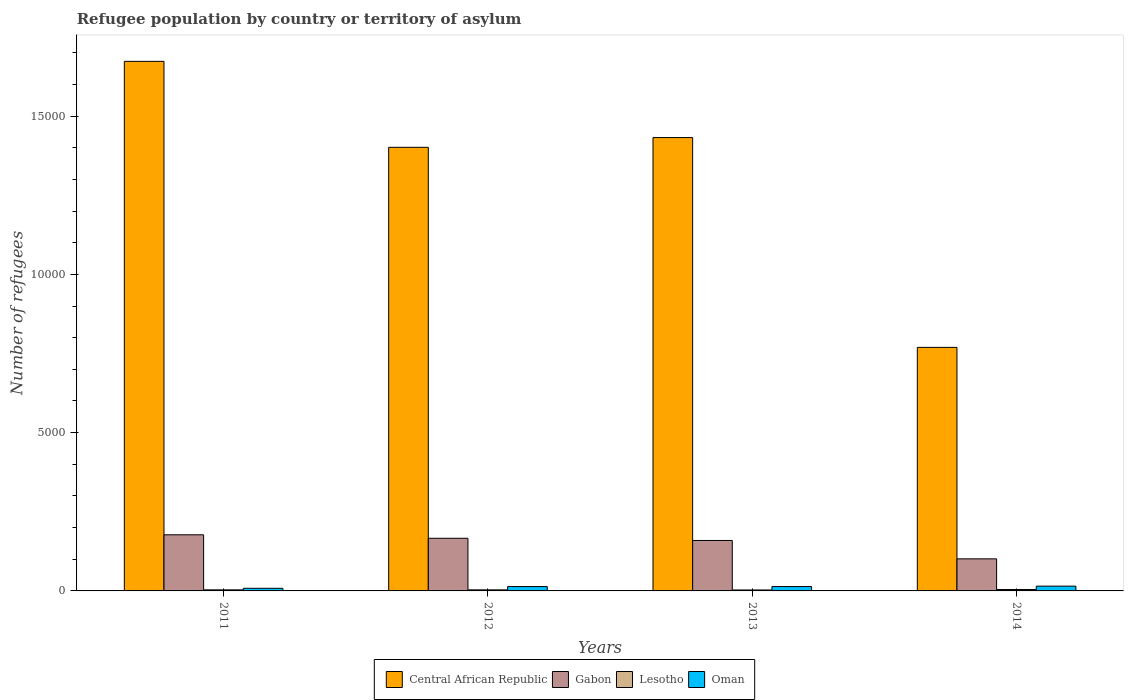How many different coloured bars are there?
Keep it short and to the point. 4. Are the number of bars on each tick of the X-axis equal?
Ensure brevity in your answer.  Yes. How many bars are there on the 2nd tick from the left?
Offer a terse response. 4. How many bars are there on the 4th tick from the right?
Provide a succinct answer. 4. In how many cases, is the number of bars for a given year not equal to the number of legend labels?
Your answer should be very brief. 0. Across all years, what is the maximum number of refugees in Oman?
Provide a succinct answer. 151. Across all years, what is the minimum number of refugees in Central African Republic?
Keep it short and to the point. 7694. What is the total number of refugees in Central African Republic in the graph?
Your response must be concise. 5.28e+04. What is the difference between the number of refugees in Lesotho in 2011 and that in 2012?
Your answer should be compact. 0. What is the difference between the number of refugees in Oman in 2014 and the number of refugees in Central African Republic in 2013?
Offer a very short reply. -1.42e+04. What is the average number of refugees in Gabon per year?
Ensure brevity in your answer.  1510.75. In the year 2013, what is the difference between the number of refugees in Central African Republic and number of refugees in Oman?
Make the answer very short. 1.42e+04. In how many years, is the number of refugees in Oman greater than 12000?
Your response must be concise. 0. What is the ratio of the number of refugees in Central African Republic in 2011 to that in 2012?
Offer a terse response. 1.19. Is the difference between the number of refugees in Central African Republic in 2011 and 2012 greater than the difference between the number of refugees in Oman in 2011 and 2012?
Your answer should be compact. Yes. What is the difference between the highest and the second highest number of refugees in Oman?
Your answer should be compact. 13. What is the difference between the highest and the lowest number of refugees in Gabon?
Ensure brevity in your answer.  760. In how many years, is the number of refugees in Gabon greater than the average number of refugees in Gabon taken over all years?
Your answer should be compact. 3. Is the sum of the number of refugees in Central African Republic in 2012 and 2013 greater than the maximum number of refugees in Gabon across all years?
Provide a succinct answer. Yes. What does the 1st bar from the left in 2013 represents?
Your answer should be compact. Central African Republic. What does the 4th bar from the right in 2011 represents?
Make the answer very short. Central African Republic. How many bars are there?
Offer a terse response. 16. Are all the bars in the graph horizontal?
Make the answer very short. No. What is the difference between two consecutive major ticks on the Y-axis?
Give a very brief answer. 5000. Are the values on the major ticks of Y-axis written in scientific E-notation?
Keep it short and to the point. No. Where does the legend appear in the graph?
Your answer should be compact. Bottom center. What is the title of the graph?
Your answer should be very brief. Refugee population by country or territory of asylum. What is the label or title of the Y-axis?
Provide a succinct answer. Number of refugees. What is the Number of refugees in Central African Republic in 2011?
Your answer should be very brief. 1.67e+04. What is the Number of refugees of Gabon in 2011?
Keep it short and to the point. 1773. What is the Number of refugees in Central African Republic in 2012?
Offer a terse response. 1.40e+04. What is the Number of refugees in Gabon in 2012?
Keep it short and to the point. 1663. What is the Number of refugees in Oman in 2012?
Provide a succinct answer. 138. What is the Number of refugees of Central African Republic in 2013?
Your answer should be very brief. 1.43e+04. What is the Number of refugees of Gabon in 2013?
Your response must be concise. 1594. What is the Number of refugees in Oman in 2013?
Your response must be concise. 138. What is the Number of refugees in Central African Republic in 2014?
Your response must be concise. 7694. What is the Number of refugees of Gabon in 2014?
Ensure brevity in your answer.  1013. What is the Number of refugees of Lesotho in 2014?
Offer a terse response. 44. What is the Number of refugees of Oman in 2014?
Your response must be concise. 151. Across all years, what is the maximum Number of refugees in Central African Republic?
Keep it short and to the point. 1.67e+04. Across all years, what is the maximum Number of refugees of Gabon?
Make the answer very short. 1773. Across all years, what is the maximum Number of refugees of Lesotho?
Your answer should be very brief. 44. Across all years, what is the maximum Number of refugees of Oman?
Your response must be concise. 151. Across all years, what is the minimum Number of refugees in Central African Republic?
Ensure brevity in your answer.  7694. Across all years, what is the minimum Number of refugees in Gabon?
Keep it short and to the point. 1013. Across all years, what is the minimum Number of refugees in Lesotho?
Your response must be concise. 30. What is the total Number of refugees of Central African Republic in the graph?
Give a very brief answer. 5.28e+04. What is the total Number of refugees in Gabon in the graph?
Your response must be concise. 6043. What is the total Number of refugees of Lesotho in the graph?
Your answer should be very brief. 142. What is the total Number of refugees of Oman in the graph?
Ensure brevity in your answer.  510. What is the difference between the Number of refugees in Central African Republic in 2011 and that in 2012?
Ensure brevity in your answer.  2716. What is the difference between the Number of refugees of Gabon in 2011 and that in 2012?
Your response must be concise. 110. What is the difference between the Number of refugees of Lesotho in 2011 and that in 2012?
Make the answer very short. 0. What is the difference between the Number of refugees of Oman in 2011 and that in 2012?
Give a very brief answer. -55. What is the difference between the Number of refugees of Central African Republic in 2011 and that in 2013?
Your response must be concise. 2408. What is the difference between the Number of refugees in Gabon in 2011 and that in 2013?
Keep it short and to the point. 179. What is the difference between the Number of refugees of Lesotho in 2011 and that in 2013?
Your answer should be very brief. 4. What is the difference between the Number of refugees in Oman in 2011 and that in 2013?
Provide a short and direct response. -55. What is the difference between the Number of refugees of Central African Republic in 2011 and that in 2014?
Offer a terse response. 9036. What is the difference between the Number of refugees of Gabon in 2011 and that in 2014?
Your response must be concise. 760. What is the difference between the Number of refugees in Lesotho in 2011 and that in 2014?
Offer a very short reply. -10. What is the difference between the Number of refugees of Oman in 2011 and that in 2014?
Keep it short and to the point. -68. What is the difference between the Number of refugees in Central African Republic in 2012 and that in 2013?
Make the answer very short. -308. What is the difference between the Number of refugees of Central African Republic in 2012 and that in 2014?
Your answer should be compact. 6320. What is the difference between the Number of refugees of Gabon in 2012 and that in 2014?
Your response must be concise. 650. What is the difference between the Number of refugees of Central African Republic in 2013 and that in 2014?
Offer a very short reply. 6628. What is the difference between the Number of refugees of Gabon in 2013 and that in 2014?
Your response must be concise. 581. What is the difference between the Number of refugees of Lesotho in 2013 and that in 2014?
Ensure brevity in your answer.  -14. What is the difference between the Number of refugees in Oman in 2013 and that in 2014?
Ensure brevity in your answer.  -13. What is the difference between the Number of refugees of Central African Republic in 2011 and the Number of refugees of Gabon in 2012?
Make the answer very short. 1.51e+04. What is the difference between the Number of refugees in Central African Republic in 2011 and the Number of refugees in Lesotho in 2012?
Your response must be concise. 1.67e+04. What is the difference between the Number of refugees of Central African Republic in 2011 and the Number of refugees of Oman in 2012?
Your response must be concise. 1.66e+04. What is the difference between the Number of refugees in Gabon in 2011 and the Number of refugees in Lesotho in 2012?
Provide a succinct answer. 1739. What is the difference between the Number of refugees of Gabon in 2011 and the Number of refugees of Oman in 2012?
Your answer should be very brief. 1635. What is the difference between the Number of refugees in Lesotho in 2011 and the Number of refugees in Oman in 2012?
Your answer should be very brief. -104. What is the difference between the Number of refugees of Central African Republic in 2011 and the Number of refugees of Gabon in 2013?
Provide a short and direct response. 1.51e+04. What is the difference between the Number of refugees in Central African Republic in 2011 and the Number of refugees in Lesotho in 2013?
Offer a terse response. 1.67e+04. What is the difference between the Number of refugees in Central African Republic in 2011 and the Number of refugees in Oman in 2013?
Offer a very short reply. 1.66e+04. What is the difference between the Number of refugees of Gabon in 2011 and the Number of refugees of Lesotho in 2013?
Your answer should be very brief. 1743. What is the difference between the Number of refugees in Gabon in 2011 and the Number of refugees in Oman in 2013?
Your answer should be very brief. 1635. What is the difference between the Number of refugees of Lesotho in 2011 and the Number of refugees of Oman in 2013?
Keep it short and to the point. -104. What is the difference between the Number of refugees of Central African Republic in 2011 and the Number of refugees of Gabon in 2014?
Ensure brevity in your answer.  1.57e+04. What is the difference between the Number of refugees of Central African Republic in 2011 and the Number of refugees of Lesotho in 2014?
Your answer should be compact. 1.67e+04. What is the difference between the Number of refugees of Central African Republic in 2011 and the Number of refugees of Oman in 2014?
Provide a short and direct response. 1.66e+04. What is the difference between the Number of refugees of Gabon in 2011 and the Number of refugees of Lesotho in 2014?
Provide a succinct answer. 1729. What is the difference between the Number of refugees in Gabon in 2011 and the Number of refugees in Oman in 2014?
Provide a short and direct response. 1622. What is the difference between the Number of refugees in Lesotho in 2011 and the Number of refugees in Oman in 2014?
Provide a succinct answer. -117. What is the difference between the Number of refugees in Central African Republic in 2012 and the Number of refugees in Gabon in 2013?
Offer a terse response. 1.24e+04. What is the difference between the Number of refugees in Central African Republic in 2012 and the Number of refugees in Lesotho in 2013?
Your answer should be compact. 1.40e+04. What is the difference between the Number of refugees in Central African Republic in 2012 and the Number of refugees in Oman in 2013?
Keep it short and to the point. 1.39e+04. What is the difference between the Number of refugees in Gabon in 2012 and the Number of refugees in Lesotho in 2013?
Provide a short and direct response. 1633. What is the difference between the Number of refugees in Gabon in 2012 and the Number of refugees in Oman in 2013?
Your response must be concise. 1525. What is the difference between the Number of refugees in Lesotho in 2012 and the Number of refugees in Oman in 2013?
Give a very brief answer. -104. What is the difference between the Number of refugees of Central African Republic in 2012 and the Number of refugees of Gabon in 2014?
Provide a succinct answer. 1.30e+04. What is the difference between the Number of refugees in Central African Republic in 2012 and the Number of refugees in Lesotho in 2014?
Ensure brevity in your answer.  1.40e+04. What is the difference between the Number of refugees in Central African Republic in 2012 and the Number of refugees in Oman in 2014?
Make the answer very short. 1.39e+04. What is the difference between the Number of refugees in Gabon in 2012 and the Number of refugees in Lesotho in 2014?
Your answer should be very brief. 1619. What is the difference between the Number of refugees of Gabon in 2012 and the Number of refugees of Oman in 2014?
Your answer should be compact. 1512. What is the difference between the Number of refugees of Lesotho in 2012 and the Number of refugees of Oman in 2014?
Make the answer very short. -117. What is the difference between the Number of refugees in Central African Republic in 2013 and the Number of refugees in Gabon in 2014?
Your answer should be very brief. 1.33e+04. What is the difference between the Number of refugees in Central African Republic in 2013 and the Number of refugees in Lesotho in 2014?
Offer a terse response. 1.43e+04. What is the difference between the Number of refugees in Central African Republic in 2013 and the Number of refugees in Oman in 2014?
Your answer should be compact. 1.42e+04. What is the difference between the Number of refugees in Gabon in 2013 and the Number of refugees in Lesotho in 2014?
Offer a terse response. 1550. What is the difference between the Number of refugees of Gabon in 2013 and the Number of refugees of Oman in 2014?
Ensure brevity in your answer.  1443. What is the difference between the Number of refugees in Lesotho in 2013 and the Number of refugees in Oman in 2014?
Offer a terse response. -121. What is the average Number of refugees of Central African Republic per year?
Provide a short and direct response. 1.32e+04. What is the average Number of refugees of Gabon per year?
Provide a succinct answer. 1510.75. What is the average Number of refugees in Lesotho per year?
Provide a short and direct response. 35.5. What is the average Number of refugees of Oman per year?
Offer a very short reply. 127.5. In the year 2011, what is the difference between the Number of refugees in Central African Republic and Number of refugees in Gabon?
Ensure brevity in your answer.  1.50e+04. In the year 2011, what is the difference between the Number of refugees in Central African Republic and Number of refugees in Lesotho?
Your answer should be compact. 1.67e+04. In the year 2011, what is the difference between the Number of refugees in Central African Republic and Number of refugees in Oman?
Make the answer very short. 1.66e+04. In the year 2011, what is the difference between the Number of refugees in Gabon and Number of refugees in Lesotho?
Offer a very short reply. 1739. In the year 2011, what is the difference between the Number of refugees in Gabon and Number of refugees in Oman?
Keep it short and to the point. 1690. In the year 2011, what is the difference between the Number of refugees in Lesotho and Number of refugees in Oman?
Provide a short and direct response. -49. In the year 2012, what is the difference between the Number of refugees of Central African Republic and Number of refugees of Gabon?
Offer a very short reply. 1.24e+04. In the year 2012, what is the difference between the Number of refugees of Central African Republic and Number of refugees of Lesotho?
Your answer should be very brief. 1.40e+04. In the year 2012, what is the difference between the Number of refugees of Central African Republic and Number of refugees of Oman?
Provide a succinct answer. 1.39e+04. In the year 2012, what is the difference between the Number of refugees of Gabon and Number of refugees of Lesotho?
Offer a terse response. 1629. In the year 2012, what is the difference between the Number of refugees in Gabon and Number of refugees in Oman?
Your answer should be compact. 1525. In the year 2012, what is the difference between the Number of refugees of Lesotho and Number of refugees of Oman?
Your response must be concise. -104. In the year 2013, what is the difference between the Number of refugees in Central African Republic and Number of refugees in Gabon?
Ensure brevity in your answer.  1.27e+04. In the year 2013, what is the difference between the Number of refugees of Central African Republic and Number of refugees of Lesotho?
Your answer should be very brief. 1.43e+04. In the year 2013, what is the difference between the Number of refugees in Central African Republic and Number of refugees in Oman?
Your answer should be compact. 1.42e+04. In the year 2013, what is the difference between the Number of refugees in Gabon and Number of refugees in Lesotho?
Make the answer very short. 1564. In the year 2013, what is the difference between the Number of refugees of Gabon and Number of refugees of Oman?
Provide a short and direct response. 1456. In the year 2013, what is the difference between the Number of refugees of Lesotho and Number of refugees of Oman?
Your answer should be very brief. -108. In the year 2014, what is the difference between the Number of refugees in Central African Republic and Number of refugees in Gabon?
Your answer should be compact. 6681. In the year 2014, what is the difference between the Number of refugees of Central African Republic and Number of refugees of Lesotho?
Offer a terse response. 7650. In the year 2014, what is the difference between the Number of refugees of Central African Republic and Number of refugees of Oman?
Your answer should be very brief. 7543. In the year 2014, what is the difference between the Number of refugees in Gabon and Number of refugees in Lesotho?
Your response must be concise. 969. In the year 2014, what is the difference between the Number of refugees of Gabon and Number of refugees of Oman?
Your answer should be compact. 862. In the year 2014, what is the difference between the Number of refugees in Lesotho and Number of refugees in Oman?
Make the answer very short. -107. What is the ratio of the Number of refugees in Central African Republic in 2011 to that in 2012?
Offer a very short reply. 1.19. What is the ratio of the Number of refugees of Gabon in 2011 to that in 2012?
Your answer should be compact. 1.07. What is the ratio of the Number of refugees of Oman in 2011 to that in 2012?
Make the answer very short. 0.6. What is the ratio of the Number of refugees of Central African Republic in 2011 to that in 2013?
Provide a succinct answer. 1.17. What is the ratio of the Number of refugees of Gabon in 2011 to that in 2013?
Give a very brief answer. 1.11. What is the ratio of the Number of refugees of Lesotho in 2011 to that in 2013?
Offer a terse response. 1.13. What is the ratio of the Number of refugees of Oman in 2011 to that in 2013?
Keep it short and to the point. 0.6. What is the ratio of the Number of refugees in Central African Republic in 2011 to that in 2014?
Offer a very short reply. 2.17. What is the ratio of the Number of refugees of Gabon in 2011 to that in 2014?
Give a very brief answer. 1.75. What is the ratio of the Number of refugees in Lesotho in 2011 to that in 2014?
Make the answer very short. 0.77. What is the ratio of the Number of refugees in Oman in 2011 to that in 2014?
Offer a terse response. 0.55. What is the ratio of the Number of refugees of Central African Republic in 2012 to that in 2013?
Make the answer very short. 0.98. What is the ratio of the Number of refugees in Gabon in 2012 to that in 2013?
Offer a terse response. 1.04. What is the ratio of the Number of refugees in Lesotho in 2012 to that in 2013?
Provide a succinct answer. 1.13. What is the ratio of the Number of refugees of Central African Republic in 2012 to that in 2014?
Your answer should be compact. 1.82. What is the ratio of the Number of refugees in Gabon in 2012 to that in 2014?
Give a very brief answer. 1.64. What is the ratio of the Number of refugees of Lesotho in 2012 to that in 2014?
Your answer should be compact. 0.77. What is the ratio of the Number of refugees of Oman in 2012 to that in 2014?
Ensure brevity in your answer.  0.91. What is the ratio of the Number of refugees of Central African Republic in 2013 to that in 2014?
Your response must be concise. 1.86. What is the ratio of the Number of refugees in Gabon in 2013 to that in 2014?
Your answer should be very brief. 1.57. What is the ratio of the Number of refugees in Lesotho in 2013 to that in 2014?
Give a very brief answer. 0.68. What is the ratio of the Number of refugees in Oman in 2013 to that in 2014?
Offer a terse response. 0.91. What is the difference between the highest and the second highest Number of refugees of Central African Republic?
Your response must be concise. 2408. What is the difference between the highest and the second highest Number of refugees of Gabon?
Provide a short and direct response. 110. What is the difference between the highest and the lowest Number of refugees in Central African Republic?
Provide a short and direct response. 9036. What is the difference between the highest and the lowest Number of refugees of Gabon?
Make the answer very short. 760. What is the difference between the highest and the lowest Number of refugees of Lesotho?
Offer a very short reply. 14. What is the difference between the highest and the lowest Number of refugees of Oman?
Provide a succinct answer. 68. 